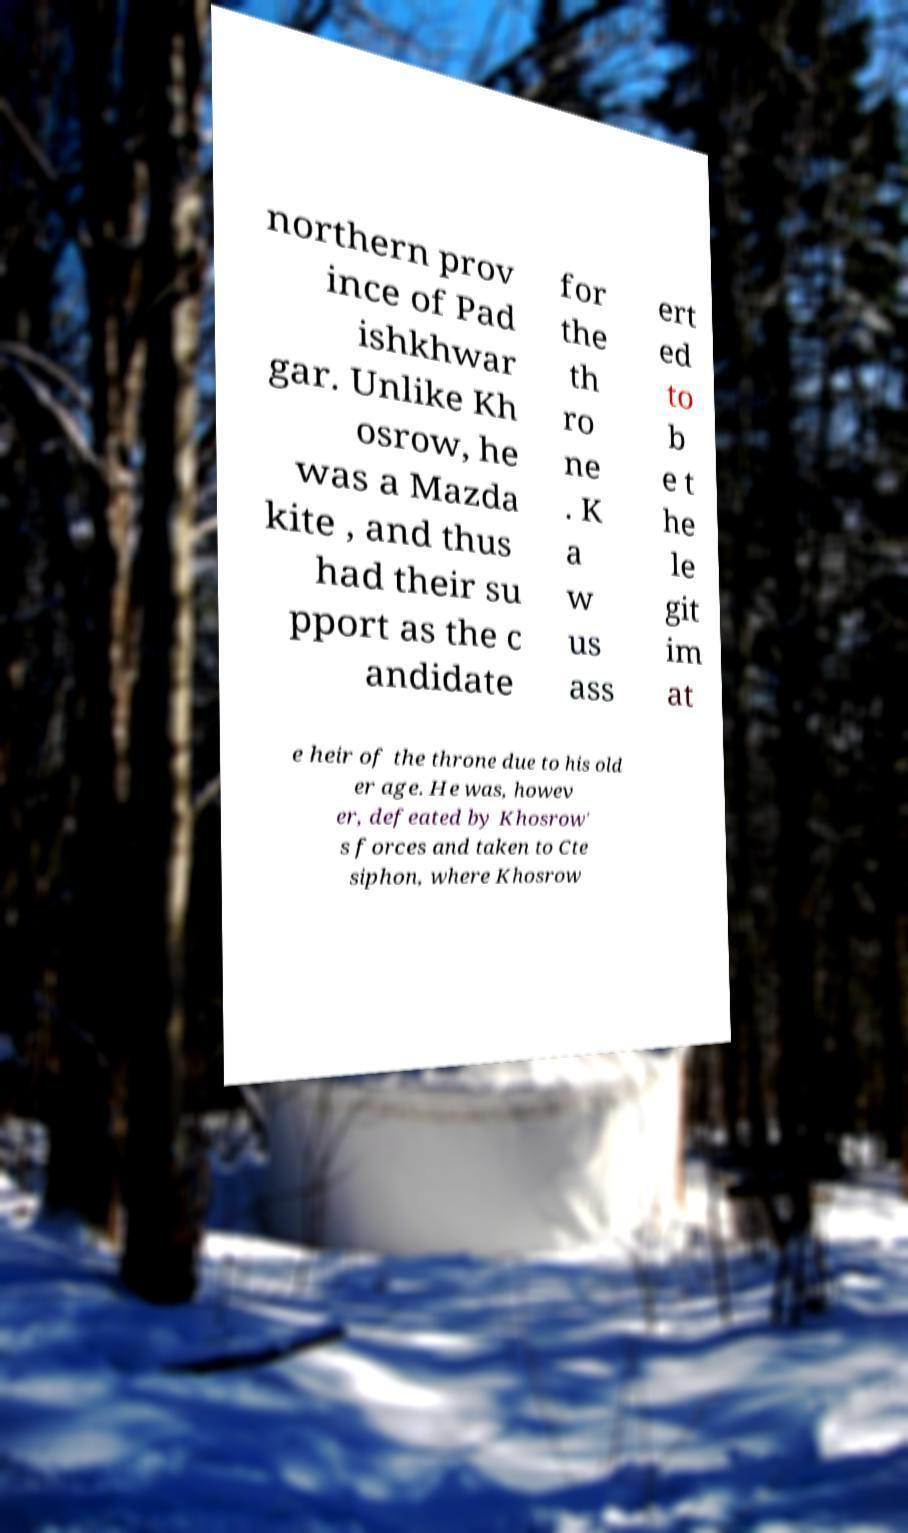I need the written content from this picture converted into text. Can you do that? northern prov ince of Pad ishkhwar gar. Unlike Kh osrow, he was a Mazda kite , and thus had their su pport as the c andidate for the th ro ne . K a w us ass ert ed to b e t he le git im at e heir of the throne due to his old er age. He was, howev er, defeated by Khosrow' s forces and taken to Cte siphon, where Khosrow 